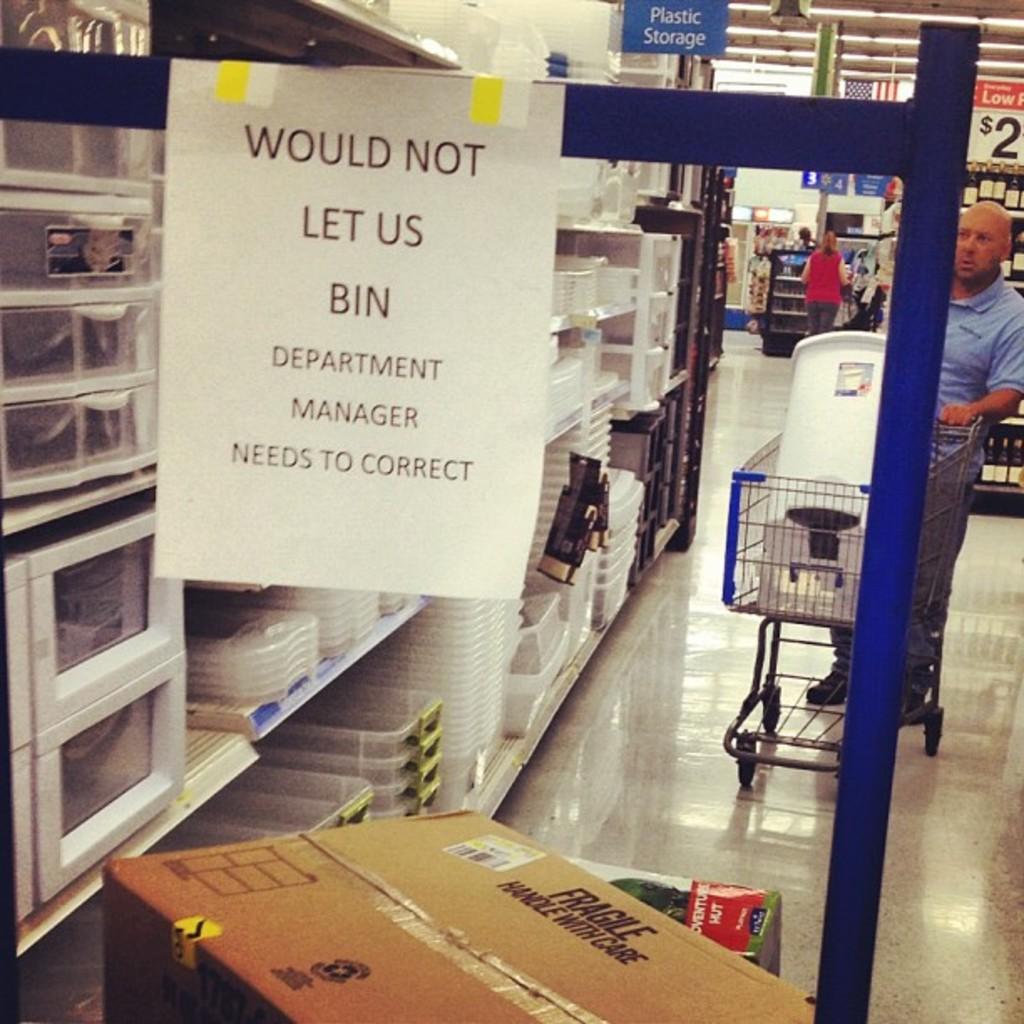Who needs to correct?
Your answer should be compact. Department manager. Who needs to make a correction?
Keep it short and to the point. Department manager. 